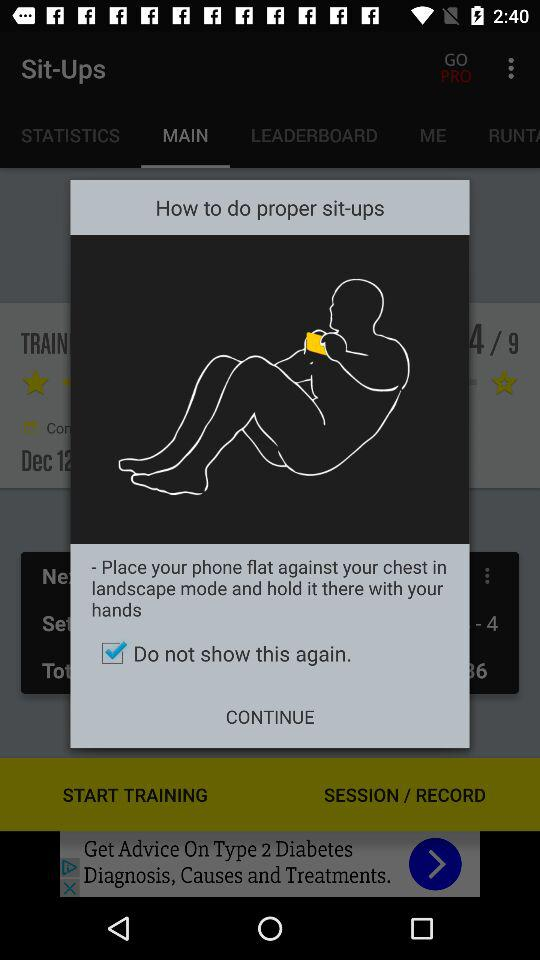In what mode should the phone be kept in order to do proper sit-ups? It should be kept in landscape mode. 